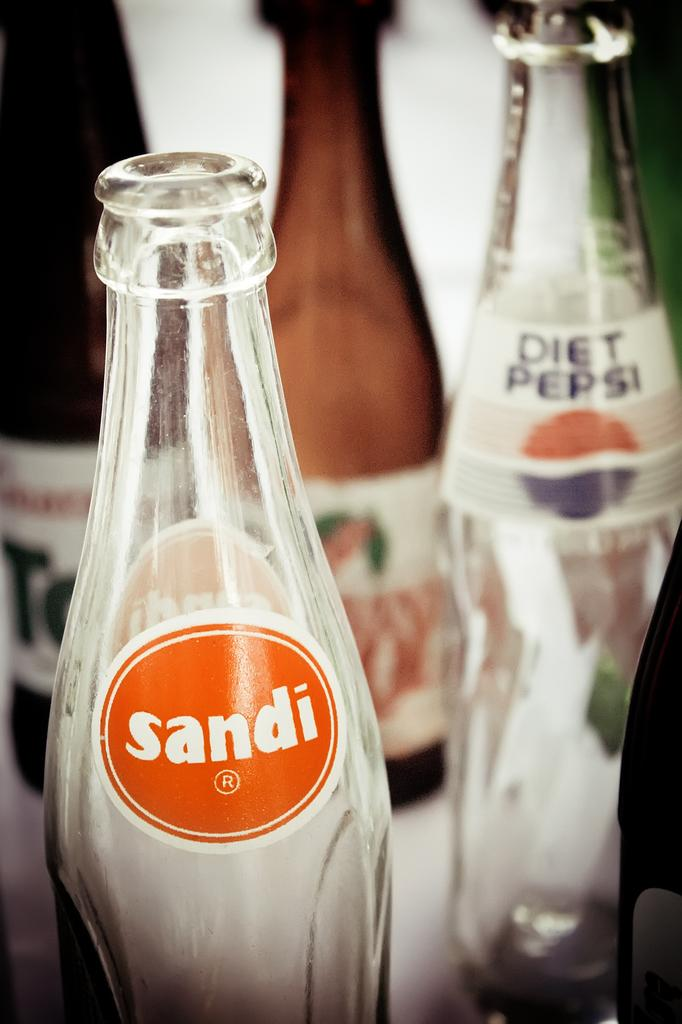<image>
Relay a brief, clear account of the picture shown. A bottle of Sandi in front of a Diet Pepsi. 